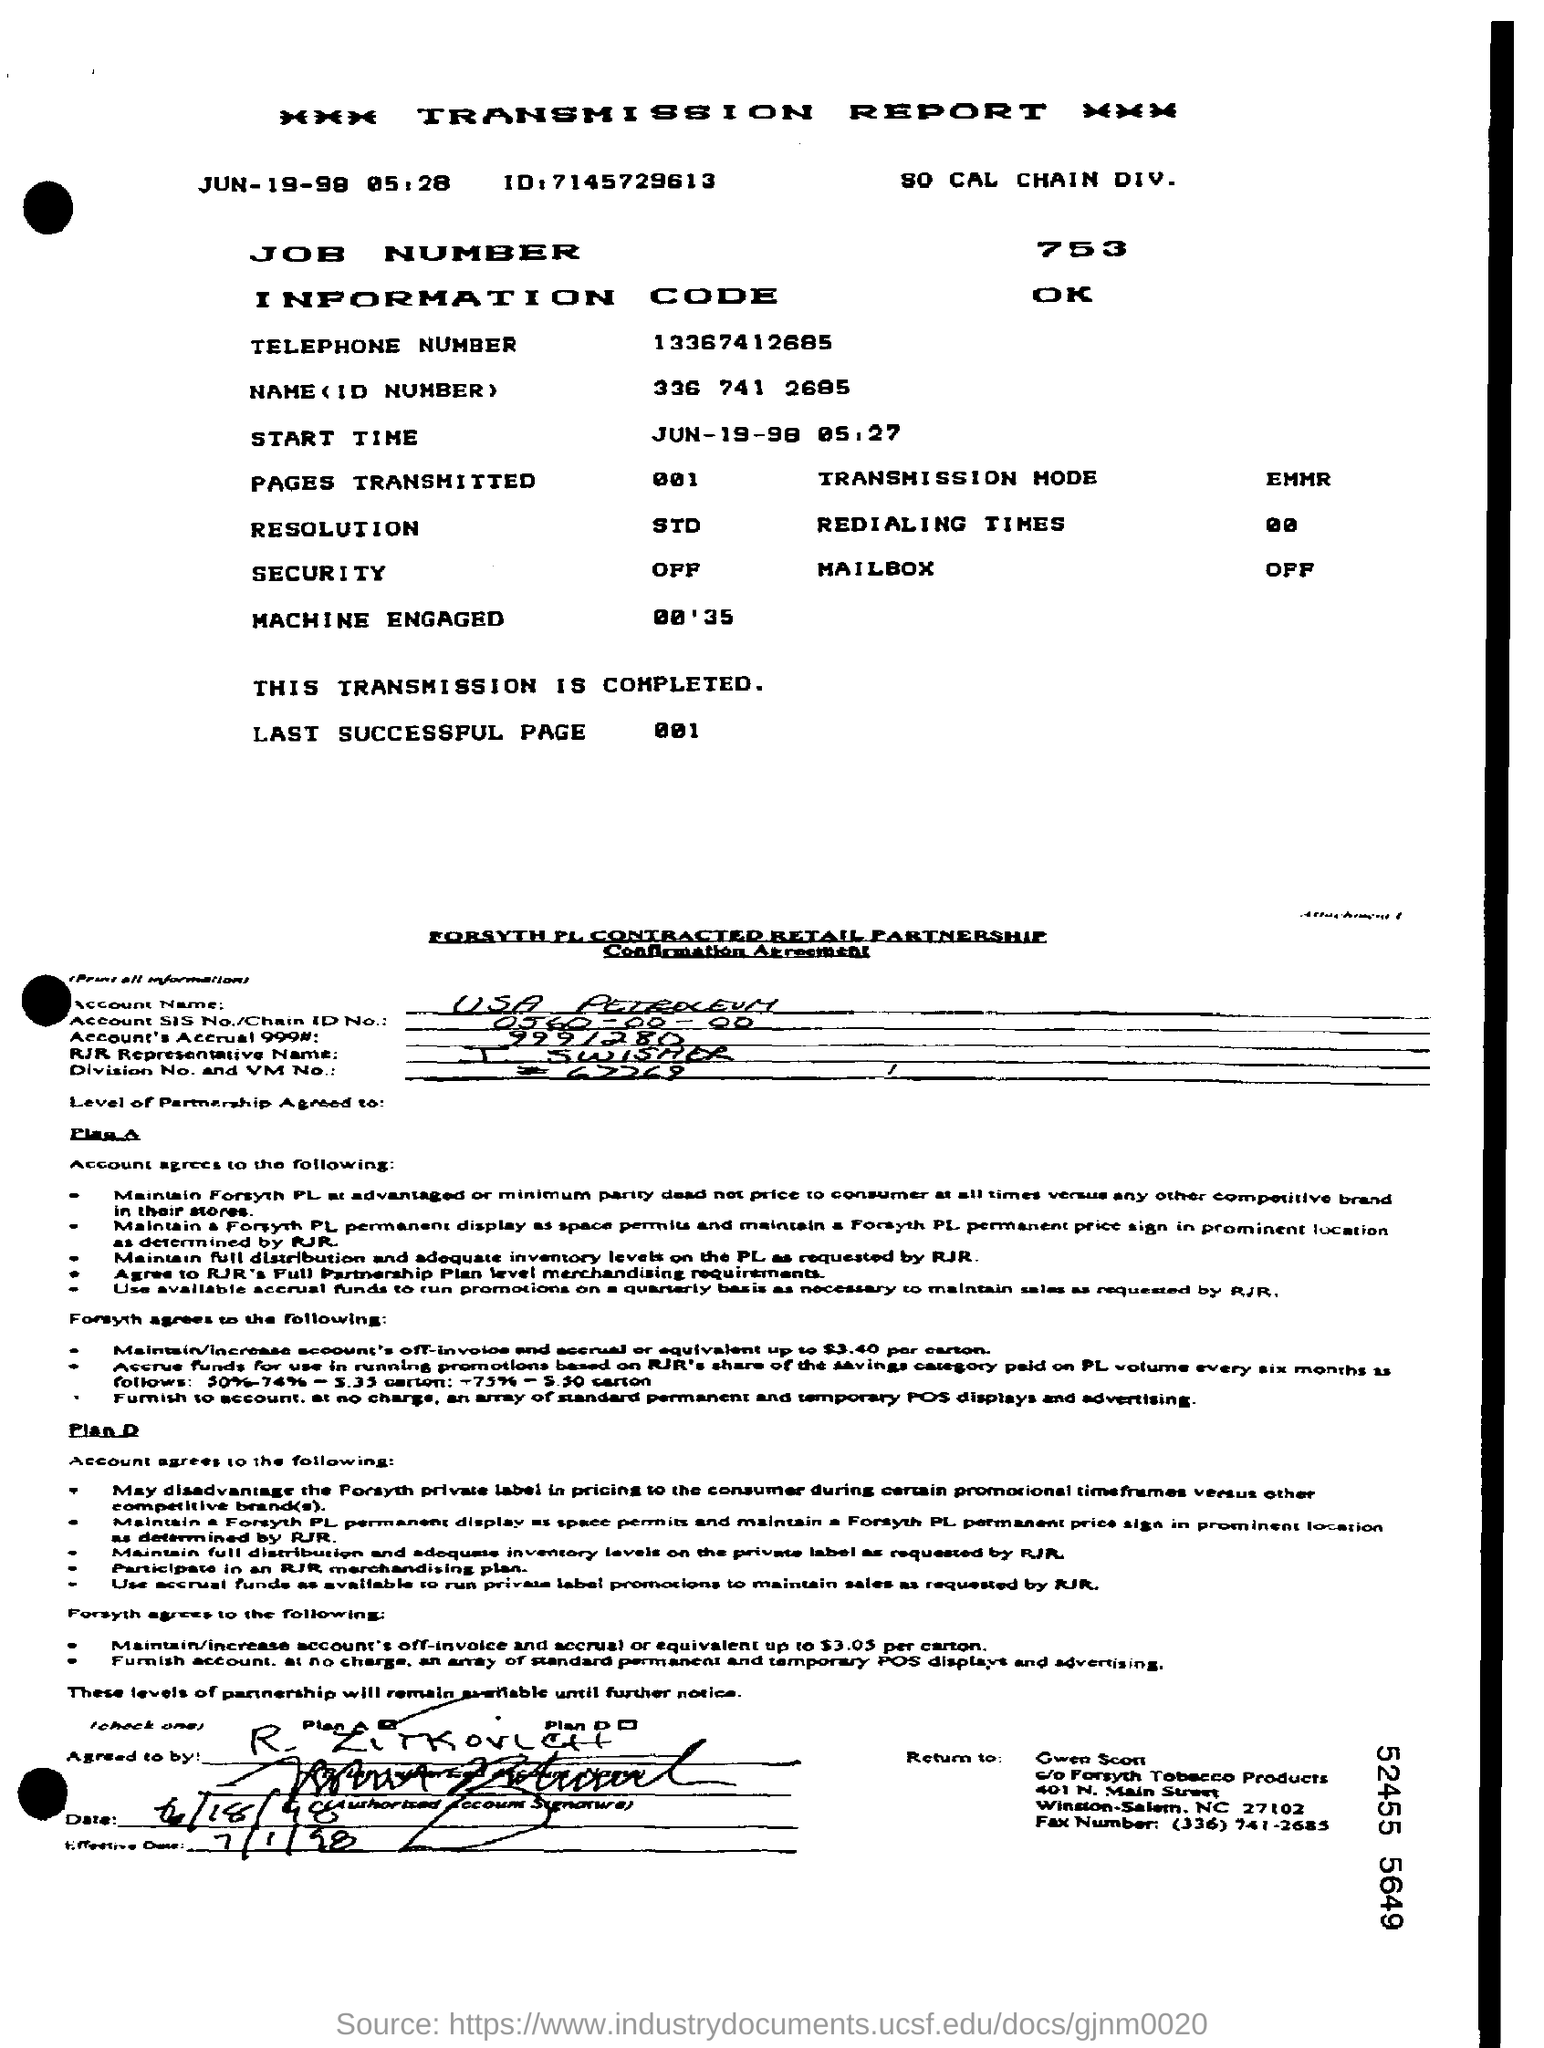Give some essential details in this illustration. The ID number mentioned in the transmission report is 3367412685. The job number given is 753... The security field contains the information 'OFF.' The Transmission Mode Field contains the value EMMR. The transmission report, as indicated in the letterhead, is written. 